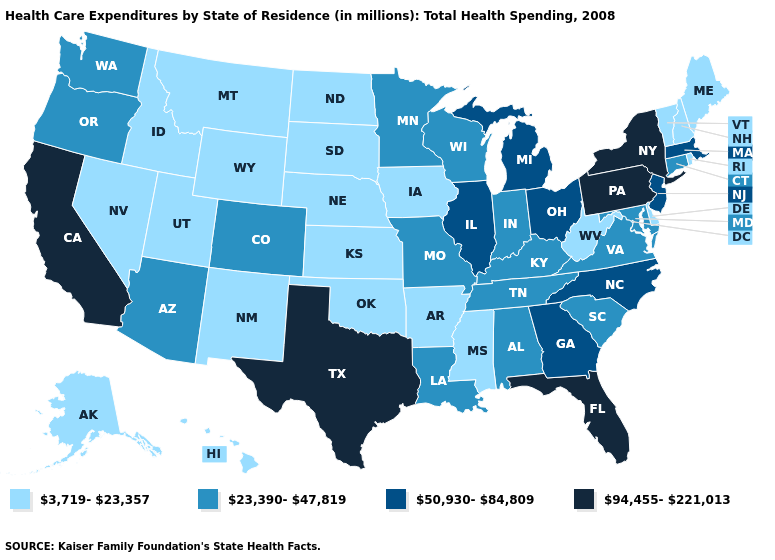Does Nebraska have a lower value than California?
Concise answer only. Yes. What is the lowest value in states that border Arizona?
Concise answer only. 3,719-23,357. Does Minnesota have the lowest value in the USA?
Give a very brief answer. No. What is the highest value in the USA?
Give a very brief answer. 94,455-221,013. Does Hawaii have the lowest value in the USA?
Keep it brief. Yes. Which states hav the highest value in the West?
Keep it brief. California. What is the value of Pennsylvania?
Keep it brief. 94,455-221,013. Name the states that have a value in the range 94,455-221,013?
Quick response, please. California, Florida, New York, Pennsylvania, Texas. Which states have the lowest value in the MidWest?
Be succinct. Iowa, Kansas, Nebraska, North Dakota, South Dakota. Name the states that have a value in the range 3,719-23,357?
Quick response, please. Alaska, Arkansas, Delaware, Hawaii, Idaho, Iowa, Kansas, Maine, Mississippi, Montana, Nebraska, Nevada, New Hampshire, New Mexico, North Dakota, Oklahoma, Rhode Island, South Dakota, Utah, Vermont, West Virginia, Wyoming. What is the value of Georgia?
Quick response, please. 50,930-84,809. Name the states that have a value in the range 3,719-23,357?
Concise answer only. Alaska, Arkansas, Delaware, Hawaii, Idaho, Iowa, Kansas, Maine, Mississippi, Montana, Nebraska, Nevada, New Hampshire, New Mexico, North Dakota, Oklahoma, Rhode Island, South Dakota, Utah, Vermont, West Virginia, Wyoming. Is the legend a continuous bar?
Keep it brief. No. 